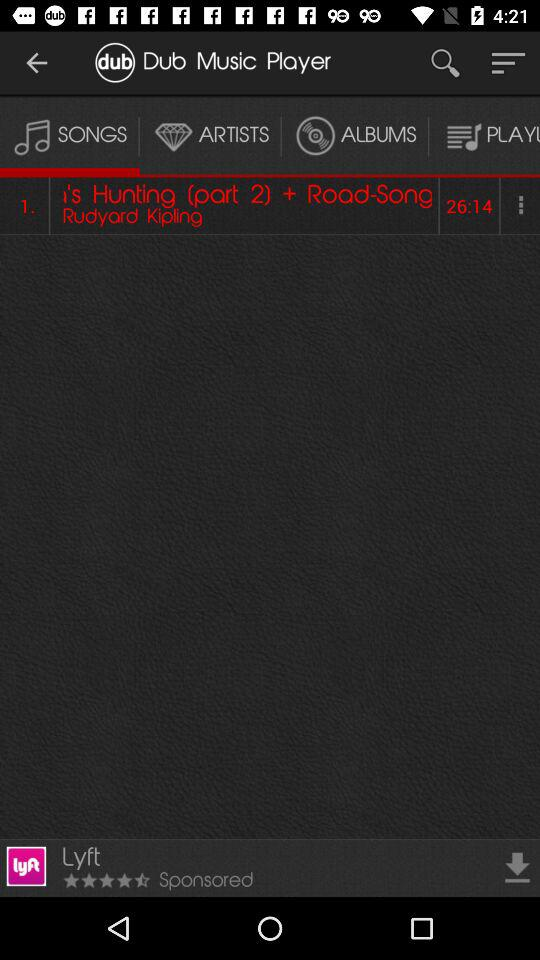What is the title of the song?
When the provided information is insufficient, respond with <no answer>. <no answer> 